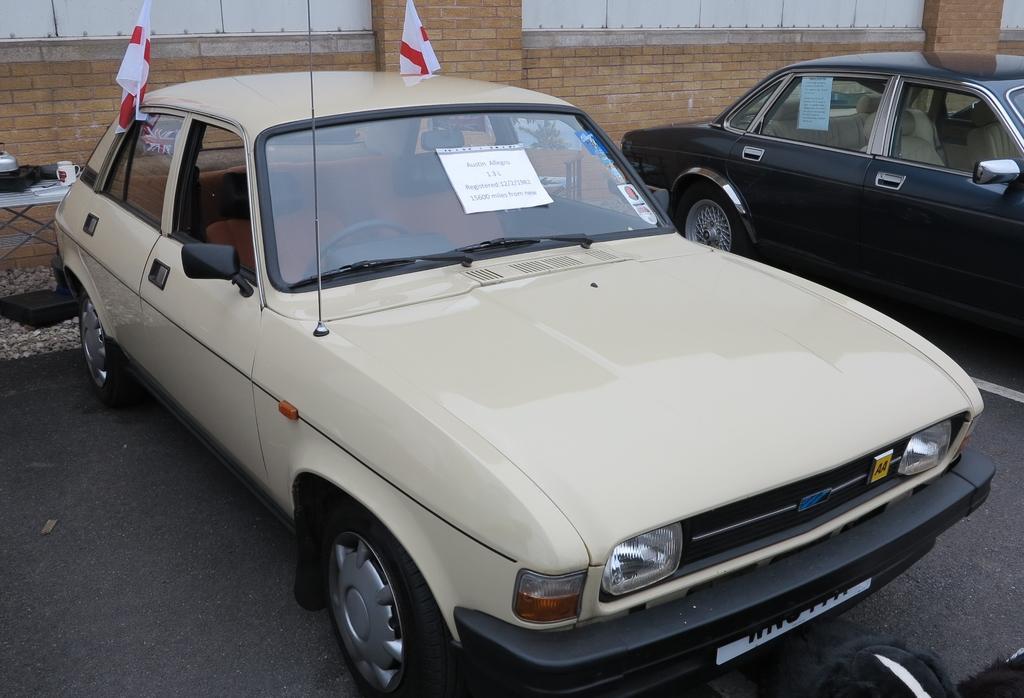How would you summarize this image in a sentence or two? In this picture I can see there are two cars parked here and one of them is in cream color and the other one is in black color. The cream color car has two flags and in the backdrop there is a wall. 